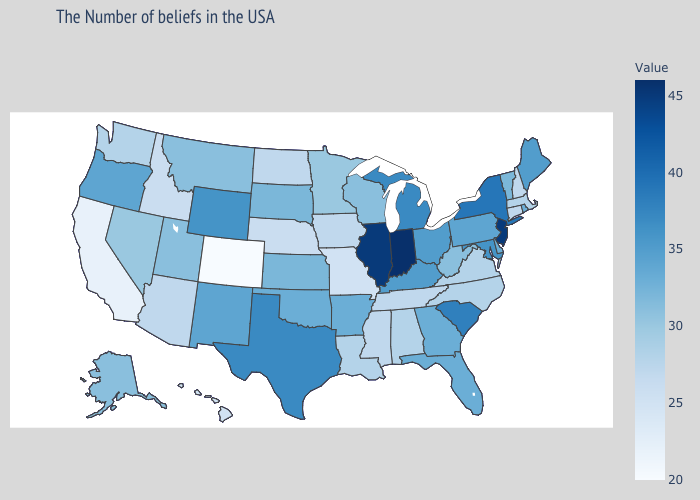Which states have the lowest value in the USA?
Give a very brief answer. Colorado. Does Minnesota have the lowest value in the MidWest?
Concise answer only. No. Which states have the lowest value in the USA?
Keep it brief. Colorado. 